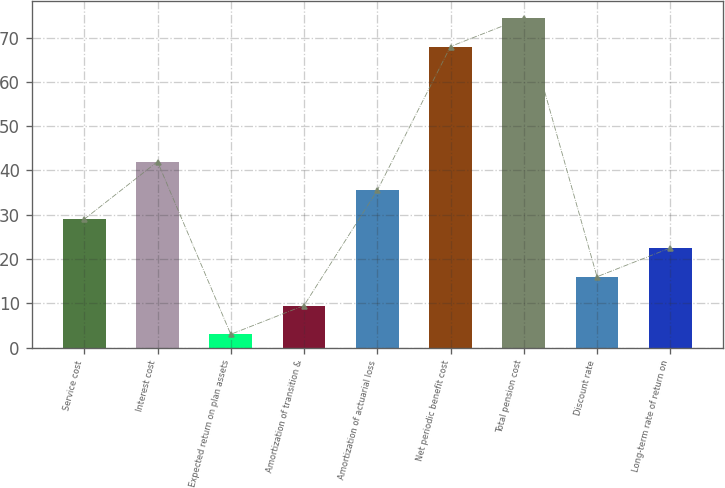<chart> <loc_0><loc_0><loc_500><loc_500><bar_chart><fcel>Service cost<fcel>Interest cost<fcel>Expected return on plan assets<fcel>Amortization of transition &<fcel>Amortization of actuarial loss<fcel>Net periodic benefit cost<fcel>Total pension cost<fcel>Discount rate<fcel>Long-term rate of return on<nl><fcel>29<fcel>42<fcel>3<fcel>9.5<fcel>35.5<fcel>68<fcel>74.5<fcel>16<fcel>22.5<nl></chart> 